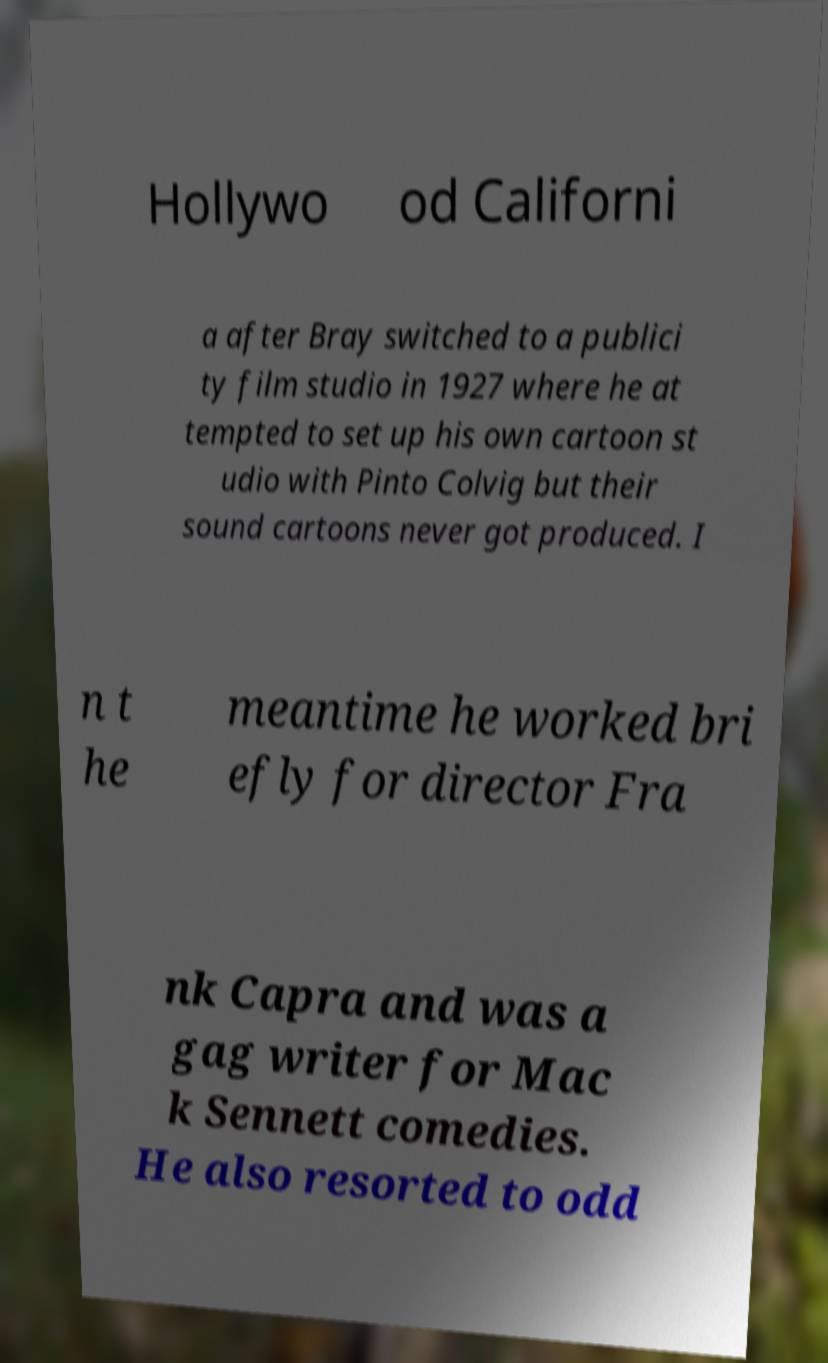Please read and relay the text visible in this image. What does it say? Hollywo od Californi a after Bray switched to a publici ty film studio in 1927 where he at tempted to set up his own cartoon st udio with Pinto Colvig but their sound cartoons never got produced. I n t he meantime he worked bri efly for director Fra nk Capra and was a gag writer for Mac k Sennett comedies. He also resorted to odd 